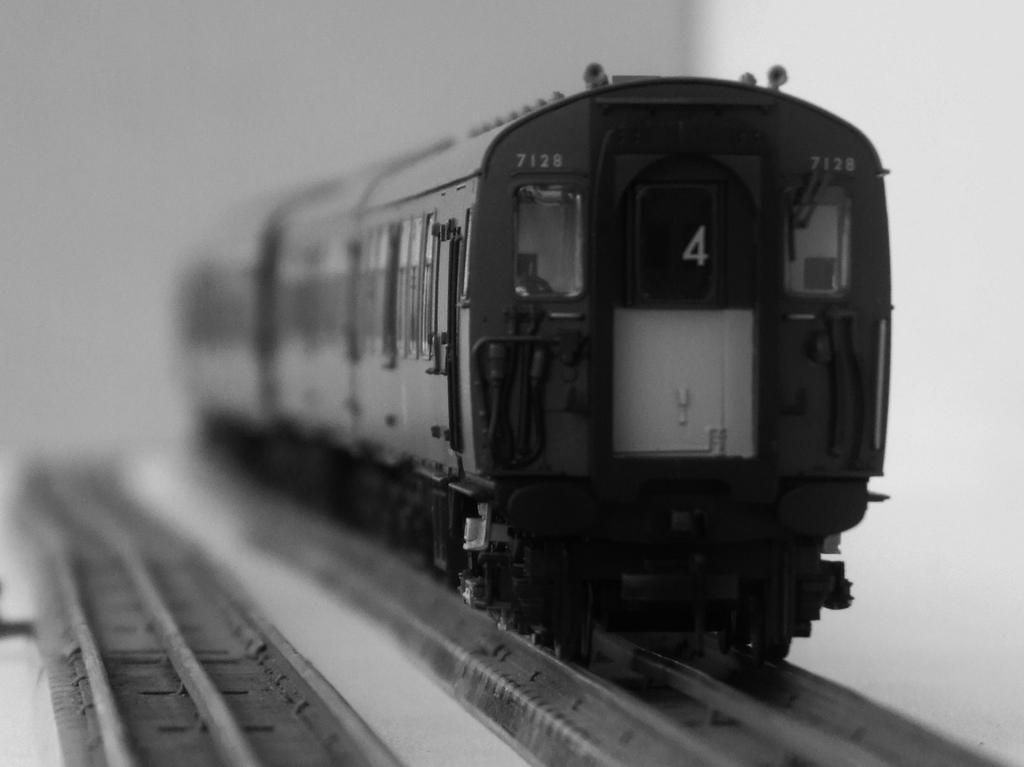Please provide a concise description of this image. This is a black and white image. There is a train on a railway track. There is another track at the left. The background is blurred. 